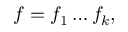Convert formula to latex. <formula><loc_0><loc_0><loc_500><loc_500>f = f _ { 1 } \dots f _ { k } ,</formula> 